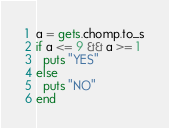<code> <loc_0><loc_0><loc_500><loc_500><_Ruby_>a = gets.chomp.to_s
if a <= 9 && a >= 1
  puts "YES"
else
  puts "NO"
end</code> 